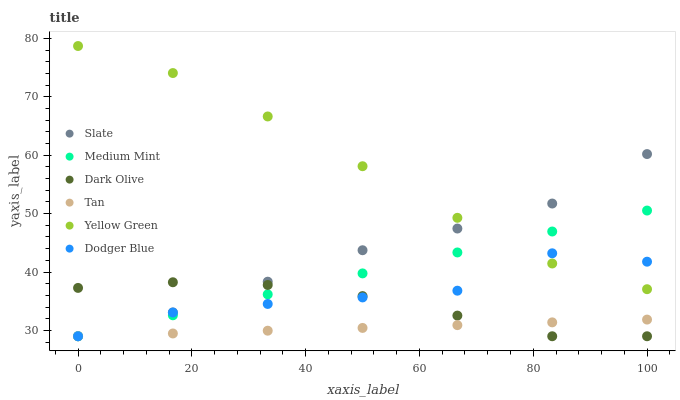Does Tan have the minimum area under the curve?
Answer yes or no. Yes. Does Yellow Green have the maximum area under the curve?
Answer yes or no. Yes. Does Slate have the minimum area under the curve?
Answer yes or no. No. Does Slate have the maximum area under the curve?
Answer yes or no. No. Is Tan the smoothest?
Answer yes or no. Yes. Is Dodger Blue the roughest?
Answer yes or no. Yes. Is Yellow Green the smoothest?
Answer yes or no. No. Is Yellow Green the roughest?
Answer yes or no. No. Does Medium Mint have the lowest value?
Answer yes or no. Yes. Does Yellow Green have the lowest value?
Answer yes or no. No. Does Yellow Green have the highest value?
Answer yes or no. Yes. Does Slate have the highest value?
Answer yes or no. No. Is Dark Olive less than Yellow Green?
Answer yes or no. Yes. Is Yellow Green greater than Tan?
Answer yes or no. Yes. Does Dodger Blue intersect Slate?
Answer yes or no. Yes. Is Dodger Blue less than Slate?
Answer yes or no. No. Is Dodger Blue greater than Slate?
Answer yes or no. No. Does Dark Olive intersect Yellow Green?
Answer yes or no. No. 